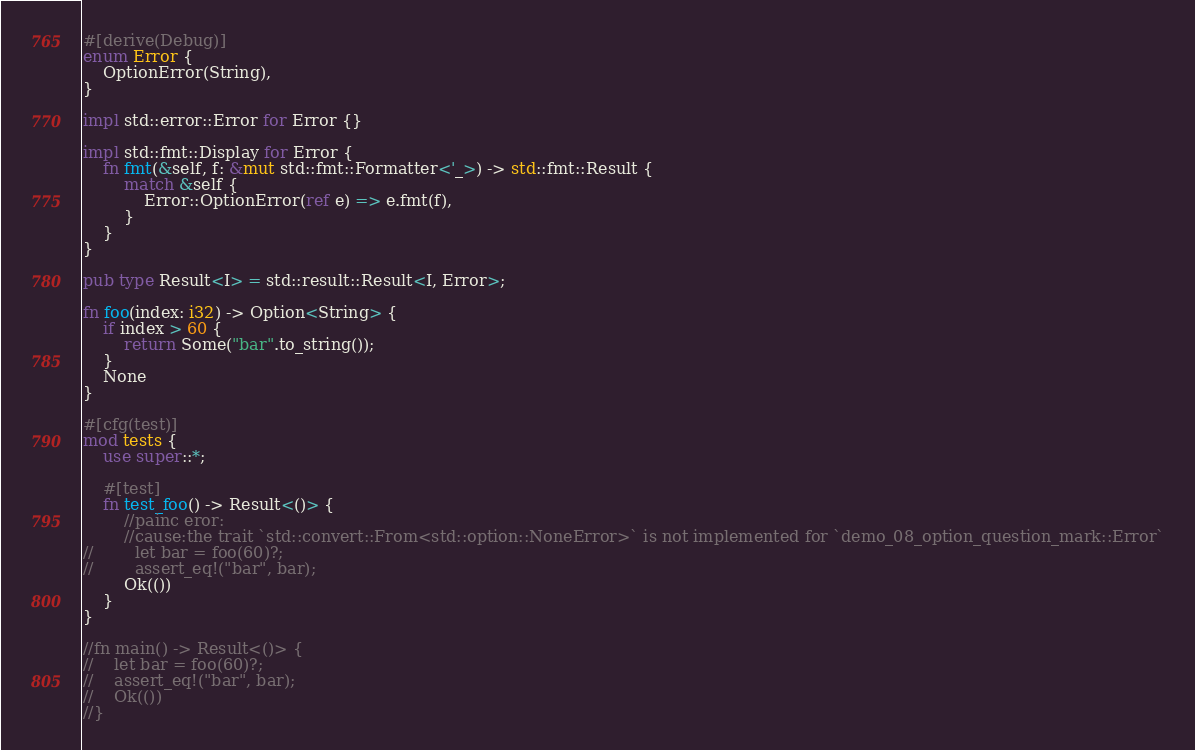Convert code to text. <code><loc_0><loc_0><loc_500><loc_500><_Rust_>#[derive(Debug)]
enum Error {
    OptionError(String),
}

impl std::error::Error for Error {}

impl std::fmt::Display for Error {
    fn fmt(&self, f: &mut std::fmt::Formatter<'_>) -> std::fmt::Result {
        match &self {
            Error::OptionError(ref e) => e.fmt(f),
        }
    }
}

pub type Result<I> = std::result::Result<I, Error>;

fn foo(index: i32) -> Option<String> {
    if index > 60 {
        return Some("bar".to_string());
    }
    None
}

#[cfg(test)]
mod tests {
    use super::*;

    #[test]
    fn test_foo() -> Result<()> {
        //painc eror:
        //cause:the trait `std::convert::From<std::option::NoneError>` is not implemented for `demo_08_option_question_mark::Error`
//        let bar = foo(60)?;
//        assert_eq!("bar", bar);
        Ok(())
    }
}

//fn main() -> Result<()> {
//    let bar = foo(60)?;
//    assert_eq!("bar", bar);
//    Ok(())
//}</code> 